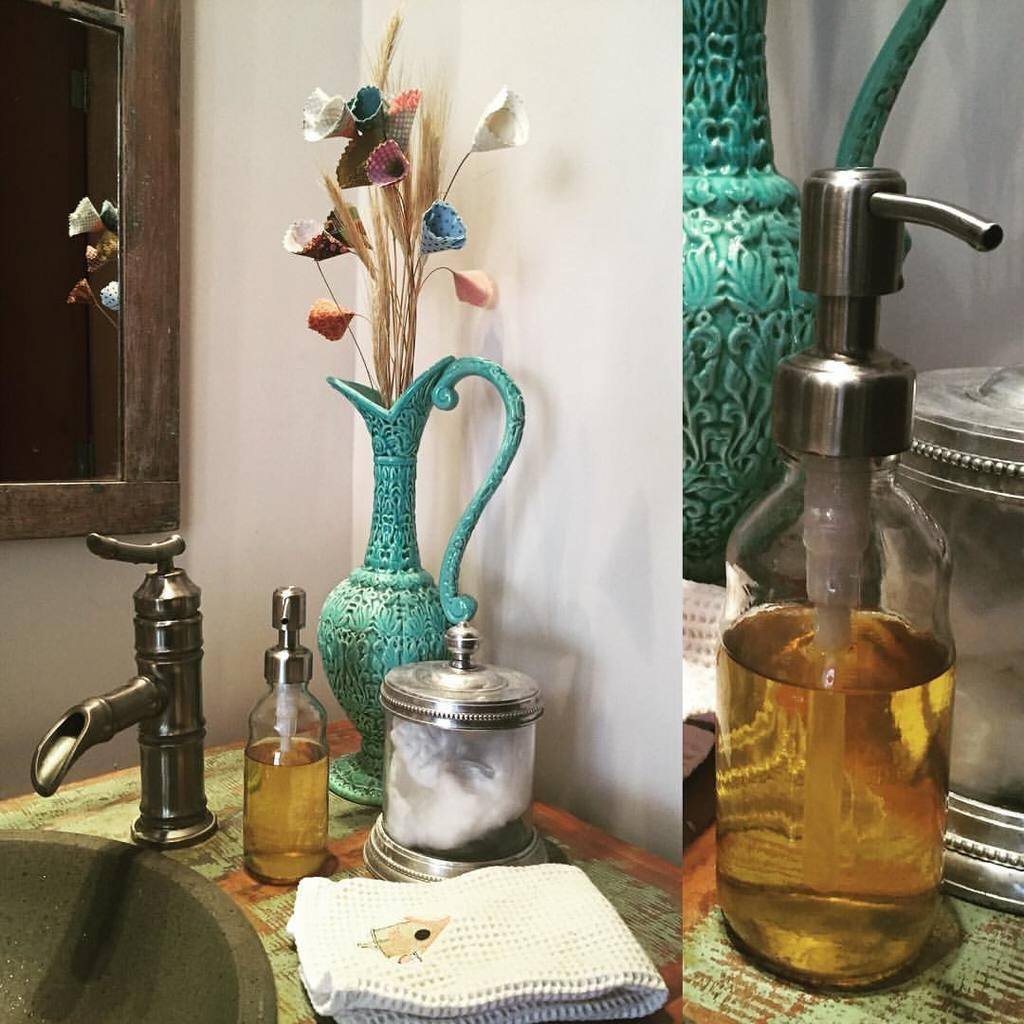What is inside the vase that is visible in the image? There is a flower in the vase in the image. What type of furniture is present in the image? There is a table in the image. What object is used for holding water or other liquids in the image? There is a basin in the image. What type of container is present in the image? There is a bottle in the image. What type of material is draped or placed in the image? There is a cloth in the image. What allows natural light to enter the room in the image? There are windows in the image. What does the mom say about the lunch in the image? There is no mention of a mom or lunch in the image; it only contains a vase with a flower, a table, a basin, a bottle, a cloth, and windows. 